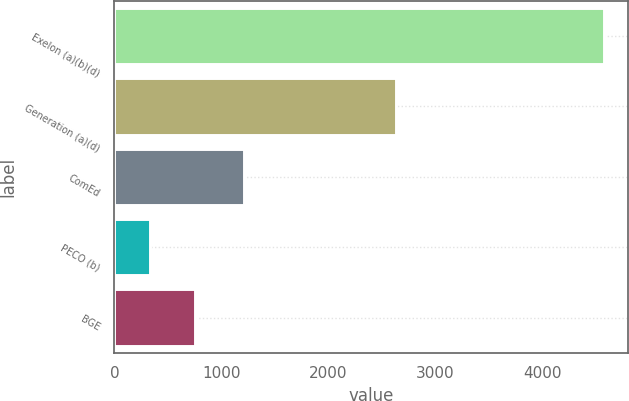Convert chart to OTSL. <chart><loc_0><loc_0><loc_500><loc_500><bar_chart><fcel>Exelon (a)(b)(d)<fcel>Generation (a)(d)<fcel>ComEd<fcel>PECO (b)<fcel>BGE<nl><fcel>4576<fcel>2629<fcel>1212<fcel>328<fcel>752.8<nl></chart> 